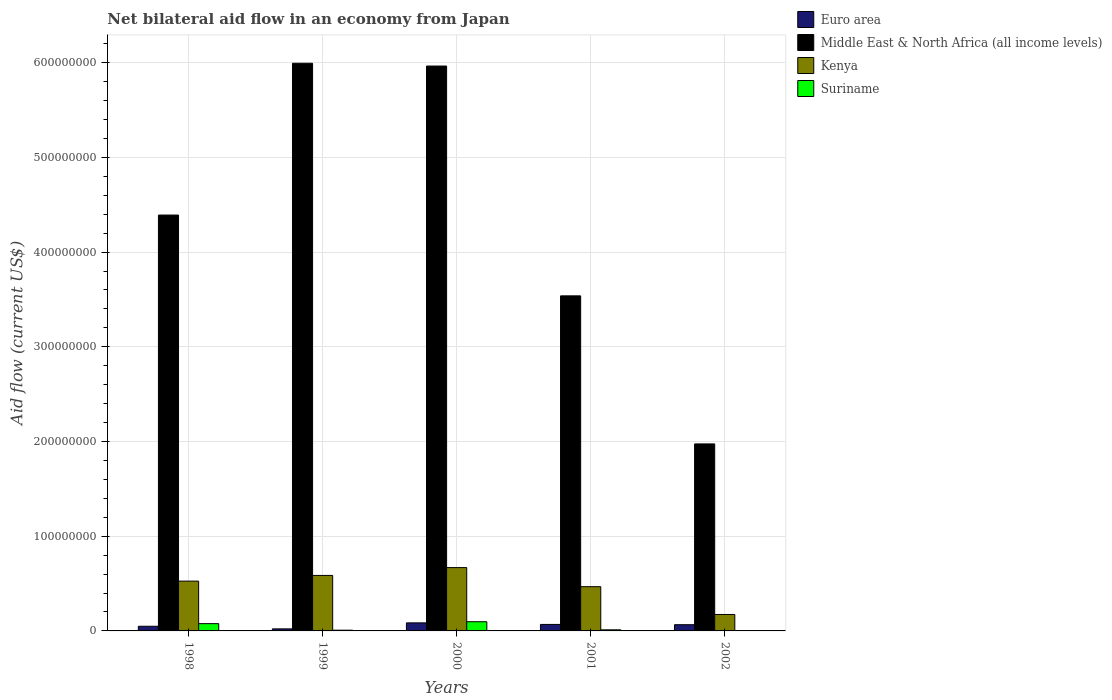How many different coloured bars are there?
Give a very brief answer. 4. How many groups of bars are there?
Your response must be concise. 5. Are the number of bars on each tick of the X-axis equal?
Provide a short and direct response. Yes. How many bars are there on the 5th tick from the left?
Your answer should be very brief. 4. What is the label of the 2nd group of bars from the left?
Your response must be concise. 1999. In how many cases, is the number of bars for a given year not equal to the number of legend labels?
Keep it short and to the point. 0. What is the net bilateral aid flow in Suriname in 2001?
Your answer should be compact. 1.17e+06. Across all years, what is the maximum net bilateral aid flow in Suriname?
Ensure brevity in your answer.  9.70e+06. Across all years, what is the minimum net bilateral aid flow in Euro area?
Offer a terse response. 2.17e+06. In which year was the net bilateral aid flow in Suriname maximum?
Provide a short and direct response. 2000. What is the total net bilateral aid flow in Suriname in the graph?
Your response must be concise. 1.97e+07. What is the difference between the net bilateral aid flow in Middle East & North Africa (all income levels) in 1998 and that in 2000?
Offer a terse response. -1.57e+08. What is the difference between the net bilateral aid flow in Euro area in 2000 and the net bilateral aid flow in Kenya in 2002?
Provide a short and direct response. -8.86e+06. What is the average net bilateral aid flow in Kenya per year?
Make the answer very short. 4.84e+07. In the year 2001, what is the difference between the net bilateral aid flow in Euro area and net bilateral aid flow in Middle East & North Africa (all income levels)?
Keep it short and to the point. -3.47e+08. In how many years, is the net bilateral aid flow in Middle East & North Africa (all income levels) greater than 480000000 US$?
Your response must be concise. 2. What is the ratio of the net bilateral aid flow in Suriname in 1999 to that in 2001?
Provide a succinct answer. 0.65. Is the net bilateral aid flow in Euro area in 1998 less than that in 1999?
Keep it short and to the point. No. Is the difference between the net bilateral aid flow in Euro area in 1998 and 1999 greater than the difference between the net bilateral aid flow in Middle East & North Africa (all income levels) in 1998 and 1999?
Offer a terse response. Yes. What is the difference between the highest and the second highest net bilateral aid flow in Suriname?
Make the answer very short. 2.02e+06. What is the difference between the highest and the lowest net bilateral aid flow in Kenya?
Ensure brevity in your answer.  4.95e+07. What does the 2nd bar from the left in 2001 represents?
Your response must be concise. Middle East & North Africa (all income levels). What does the 3rd bar from the right in 2001 represents?
Offer a very short reply. Middle East & North Africa (all income levels). Is it the case that in every year, the sum of the net bilateral aid flow in Middle East & North Africa (all income levels) and net bilateral aid flow in Euro area is greater than the net bilateral aid flow in Suriname?
Your answer should be very brief. Yes. How many bars are there?
Make the answer very short. 20. Are all the bars in the graph horizontal?
Make the answer very short. No. How many years are there in the graph?
Keep it short and to the point. 5. What is the difference between two consecutive major ticks on the Y-axis?
Offer a terse response. 1.00e+08. Are the values on the major ticks of Y-axis written in scientific E-notation?
Keep it short and to the point. No. Does the graph contain any zero values?
Make the answer very short. No. Does the graph contain grids?
Your answer should be very brief. Yes. Where does the legend appear in the graph?
Provide a succinct answer. Top right. How are the legend labels stacked?
Your answer should be compact. Vertical. What is the title of the graph?
Provide a short and direct response. Net bilateral aid flow in an economy from Japan. Does "Angola" appear as one of the legend labels in the graph?
Make the answer very short. No. What is the Aid flow (current US$) of Euro area in 1998?
Your answer should be very brief. 4.93e+06. What is the Aid flow (current US$) in Middle East & North Africa (all income levels) in 1998?
Offer a very short reply. 4.39e+08. What is the Aid flow (current US$) of Kenya in 1998?
Your response must be concise. 5.26e+07. What is the Aid flow (current US$) in Suriname in 1998?
Offer a terse response. 7.68e+06. What is the Aid flow (current US$) in Euro area in 1999?
Your response must be concise. 2.17e+06. What is the Aid flow (current US$) of Middle East & North Africa (all income levels) in 1999?
Your response must be concise. 5.99e+08. What is the Aid flow (current US$) in Kenya in 1999?
Give a very brief answer. 5.86e+07. What is the Aid flow (current US$) of Suriname in 1999?
Provide a short and direct response. 7.60e+05. What is the Aid flow (current US$) in Euro area in 2000?
Ensure brevity in your answer.  8.50e+06. What is the Aid flow (current US$) of Middle East & North Africa (all income levels) in 2000?
Ensure brevity in your answer.  5.96e+08. What is the Aid flow (current US$) of Kenya in 2000?
Offer a very short reply. 6.69e+07. What is the Aid flow (current US$) in Suriname in 2000?
Provide a succinct answer. 9.70e+06. What is the Aid flow (current US$) in Euro area in 2001?
Your answer should be very brief. 6.85e+06. What is the Aid flow (current US$) of Middle East & North Africa (all income levels) in 2001?
Offer a terse response. 3.54e+08. What is the Aid flow (current US$) of Kenya in 2001?
Keep it short and to the point. 4.67e+07. What is the Aid flow (current US$) in Suriname in 2001?
Offer a terse response. 1.17e+06. What is the Aid flow (current US$) of Euro area in 2002?
Offer a terse response. 6.58e+06. What is the Aid flow (current US$) in Middle East & North Africa (all income levels) in 2002?
Make the answer very short. 1.97e+08. What is the Aid flow (current US$) in Kenya in 2002?
Offer a terse response. 1.74e+07. What is the Aid flow (current US$) of Suriname in 2002?
Offer a terse response. 3.80e+05. Across all years, what is the maximum Aid flow (current US$) of Euro area?
Your answer should be compact. 8.50e+06. Across all years, what is the maximum Aid flow (current US$) in Middle East & North Africa (all income levels)?
Ensure brevity in your answer.  5.99e+08. Across all years, what is the maximum Aid flow (current US$) of Kenya?
Ensure brevity in your answer.  6.69e+07. Across all years, what is the maximum Aid flow (current US$) in Suriname?
Offer a terse response. 9.70e+06. Across all years, what is the minimum Aid flow (current US$) of Euro area?
Offer a very short reply. 2.17e+06. Across all years, what is the minimum Aid flow (current US$) in Middle East & North Africa (all income levels)?
Your answer should be very brief. 1.97e+08. Across all years, what is the minimum Aid flow (current US$) of Kenya?
Make the answer very short. 1.74e+07. What is the total Aid flow (current US$) of Euro area in the graph?
Offer a very short reply. 2.90e+07. What is the total Aid flow (current US$) of Middle East & North Africa (all income levels) in the graph?
Give a very brief answer. 2.19e+09. What is the total Aid flow (current US$) in Kenya in the graph?
Provide a short and direct response. 2.42e+08. What is the total Aid flow (current US$) in Suriname in the graph?
Provide a succinct answer. 1.97e+07. What is the difference between the Aid flow (current US$) of Euro area in 1998 and that in 1999?
Ensure brevity in your answer.  2.76e+06. What is the difference between the Aid flow (current US$) of Middle East & North Africa (all income levels) in 1998 and that in 1999?
Keep it short and to the point. -1.60e+08. What is the difference between the Aid flow (current US$) in Kenya in 1998 and that in 1999?
Keep it short and to the point. -6.00e+06. What is the difference between the Aid flow (current US$) in Suriname in 1998 and that in 1999?
Your response must be concise. 6.92e+06. What is the difference between the Aid flow (current US$) of Euro area in 1998 and that in 2000?
Offer a very short reply. -3.57e+06. What is the difference between the Aid flow (current US$) of Middle East & North Africa (all income levels) in 1998 and that in 2000?
Ensure brevity in your answer.  -1.57e+08. What is the difference between the Aid flow (current US$) of Kenya in 1998 and that in 2000?
Offer a very short reply. -1.43e+07. What is the difference between the Aid flow (current US$) in Suriname in 1998 and that in 2000?
Provide a succinct answer. -2.02e+06. What is the difference between the Aid flow (current US$) of Euro area in 1998 and that in 2001?
Provide a succinct answer. -1.92e+06. What is the difference between the Aid flow (current US$) of Middle East & North Africa (all income levels) in 1998 and that in 2001?
Make the answer very short. 8.53e+07. What is the difference between the Aid flow (current US$) in Kenya in 1998 and that in 2001?
Provide a succinct answer. 5.88e+06. What is the difference between the Aid flow (current US$) in Suriname in 1998 and that in 2001?
Give a very brief answer. 6.51e+06. What is the difference between the Aid flow (current US$) of Euro area in 1998 and that in 2002?
Offer a terse response. -1.65e+06. What is the difference between the Aid flow (current US$) of Middle East & North Africa (all income levels) in 1998 and that in 2002?
Provide a short and direct response. 2.42e+08. What is the difference between the Aid flow (current US$) of Kenya in 1998 and that in 2002?
Offer a very short reply. 3.52e+07. What is the difference between the Aid flow (current US$) in Suriname in 1998 and that in 2002?
Provide a short and direct response. 7.30e+06. What is the difference between the Aid flow (current US$) of Euro area in 1999 and that in 2000?
Ensure brevity in your answer.  -6.33e+06. What is the difference between the Aid flow (current US$) in Middle East & North Africa (all income levels) in 1999 and that in 2000?
Keep it short and to the point. 2.94e+06. What is the difference between the Aid flow (current US$) of Kenya in 1999 and that in 2000?
Provide a succinct answer. -8.27e+06. What is the difference between the Aid flow (current US$) in Suriname in 1999 and that in 2000?
Offer a terse response. -8.94e+06. What is the difference between the Aid flow (current US$) in Euro area in 1999 and that in 2001?
Give a very brief answer. -4.68e+06. What is the difference between the Aid flow (current US$) of Middle East & North Africa (all income levels) in 1999 and that in 2001?
Your answer should be very brief. 2.46e+08. What is the difference between the Aid flow (current US$) of Kenya in 1999 and that in 2001?
Give a very brief answer. 1.19e+07. What is the difference between the Aid flow (current US$) of Suriname in 1999 and that in 2001?
Your answer should be compact. -4.10e+05. What is the difference between the Aid flow (current US$) of Euro area in 1999 and that in 2002?
Provide a short and direct response. -4.41e+06. What is the difference between the Aid flow (current US$) in Middle East & North Africa (all income levels) in 1999 and that in 2002?
Provide a succinct answer. 4.02e+08. What is the difference between the Aid flow (current US$) of Kenya in 1999 and that in 2002?
Provide a short and direct response. 4.12e+07. What is the difference between the Aid flow (current US$) in Euro area in 2000 and that in 2001?
Your response must be concise. 1.65e+06. What is the difference between the Aid flow (current US$) in Middle East & North Africa (all income levels) in 2000 and that in 2001?
Give a very brief answer. 2.43e+08. What is the difference between the Aid flow (current US$) in Kenya in 2000 and that in 2001?
Offer a very short reply. 2.02e+07. What is the difference between the Aid flow (current US$) in Suriname in 2000 and that in 2001?
Make the answer very short. 8.53e+06. What is the difference between the Aid flow (current US$) of Euro area in 2000 and that in 2002?
Keep it short and to the point. 1.92e+06. What is the difference between the Aid flow (current US$) of Middle East & North Africa (all income levels) in 2000 and that in 2002?
Offer a terse response. 3.99e+08. What is the difference between the Aid flow (current US$) of Kenya in 2000 and that in 2002?
Offer a very short reply. 4.95e+07. What is the difference between the Aid flow (current US$) of Suriname in 2000 and that in 2002?
Provide a short and direct response. 9.32e+06. What is the difference between the Aid flow (current US$) of Euro area in 2001 and that in 2002?
Your answer should be compact. 2.70e+05. What is the difference between the Aid flow (current US$) of Middle East & North Africa (all income levels) in 2001 and that in 2002?
Offer a very short reply. 1.56e+08. What is the difference between the Aid flow (current US$) of Kenya in 2001 and that in 2002?
Offer a terse response. 2.94e+07. What is the difference between the Aid flow (current US$) in Suriname in 2001 and that in 2002?
Keep it short and to the point. 7.90e+05. What is the difference between the Aid flow (current US$) in Euro area in 1998 and the Aid flow (current US$) in Middle East & North Africa (all income levels) in 1999?
Keep it short and to the point. -5.94e+08. What is the difference between the Aid flow (current US$) of Euro area in 1998 and the Aid flow (current US$) of Kenya in 1999?
Provide a succinct answer. -5.37e+07. What is the difference between the Aid flow (current US$) in Euro area in 1998 and the Aid flow (current US$) in Suriname in 1999?
Make the answer very short. 4.17e+06. What is the difference between the Aid flow (current US$) of Middle East & North Africa (all income levels) in 1998 and the Aid flow (current US$) of Kenya in 1999?
Offer a terse response. 3.81e+08. What is the difference between the Aid flow (current US$) of Middle East & North Africa (all income levels) in 1998 and the Aid flow (current US$) of Suriname in 1999?
Your response must be concise. 4.38e+08. What is the difference between the Aid flow (current US$) of Kenya in 1998 and the Aid flow (current US$) of Suriname in 1999?
Offer a very short reply. 5.18e+07. What is the difference between the Aid flow (current US$) in Euro area in 1998 and the Aid flow (current US$) in Middle East & North Africa (all income levels) in 2000?
Your response must be concise. -5.92e+08. What is the difference between the Aid flow (current US$) in Euro area in 1998 and the Aid flow (current US$) in Kenya in 2000?
Keep it short and to the point. -6.19e+07. What is the difference between the Aid flow (current US$) of Euro area in 1998 and the Aid flow (current US$) of Suriname in 2000?
Your response must be concise. -4.77e+06. What is the difference between the Aid flow (current US$) of Middle East & North Africa (all income levels) in 1998 and the Aid flow (current US$) of Kenya in 2000?
Keep it short and to the point. 3.72e+08. What is the difference between the Aid flow (current US$) in Middle East & North Africa (all income levels) in 1998 and the Aid flow (current US$) in Suriname in 2000?
Offer a very short reply. 4.29e+08. What is the difference between the Aid flow (current US$) of Kenya in 1998 and the Aid flow (current US$) of Suriname in 2000?
Give a very brief answer. 4.29e+07. What is the difference between the Aid flow (current US$) of Euro area in 1998 and the Aid flow (current US$) of Middle East & North Africa (all income levels) in 2001?
Make the answer very short. -3.49e+08. What is the difference between the Aid flow (current US$) in Euro area in 1998 and the Aid flow (current US$) in Kenya in 2001?
Provide a short and direct response. -4.18e+07. What is the difference between the Aid flow (current US$) of Euro area in 1998 and the Aid flow (current US$) of Suriname in 2001?
Offer a very short reply. 3.76e+06. What is the difference between the Aid flow (current US$) in Middle East & North Africa (all income levels) in 1998 and the Aid flow (current US$) in Kenya in 2001?
Give a very brief answer. 3.92e+08. What is the difference between the Aid flow (current US$) in Middle East & North Africa (all income levels) in 1998 and the Aid flow (current US$) in Suriname in 2001?
Offer a very short reply. 4.38e+08. What is the difference between the Aid flow (current US$) of Kenya in 1998 and the Aid flow (current US$) of Suriname in 2001?
Provide a succinct answer. 5.14e+07. What is the difference between the Aid flow (current US$) of Euro area in 1998 and the Aid flow (current US$) of Middle East & North Africa (all income levels) in 2002?
Offer a very short reply. -1.93e+08. What is the difference between the Aid flow (current US$) in Euro area in 1998 and the Aid flow (current US$) in Kenya in 2002?
Your response must be concise. -1.24e+07. What is the difference between the Aid flow (current US$) in Euro area in 1998 and the Aid flow (current US$) in Suriname in 2002?
Your response must be concise. 4.55e+06. What is the difference between the Aid flow (current US$) of Middle East & North Africa (all income levels) in 1998 and the Aid flow (current US$) of Kenya in 2002?
Your response must be concise. 4.22e+08. What is the difference between the Aid flow (current US$) of Middle East & North Africa (all income levels) in 1998 and the Aid flow (current US$) of Suriname in 2002?
Your answer should be very brief. 4.39e+08. What is the difference between the Aid flow (current US$) in Kenya in 1998 and the Aid flow (current US$) in Suriname in 2002?
Your answer should be compact. 5.22e+07. What is the difference between the Aid flow (current US$) of Euro area in 1999 and the Aid flow (current US$) of Middle East & North Africa (all income levels) in 2000?
Keep it short and to the point. -5.94e+08. What is the difference between the Aid flow (current US$) in Euro area in 1999 and the Aid flow (current US$) in Kenya in 2000?
Offer a very short reply. -6.47e+07. What is the difference between the Aid flow (current US$) of Euro area in 1999 and the Aid flow (current US$) of Suriname in 2000?
Keep it short and to the point. -7.53e+06. What is the difference between the Aid flow (current US$) of Middle East & North Africa (all income levels) in 1999 and the Aid flow (current US$) of Kenya in 2000?
Your answer should be compact. 5.33e+08. What is the difference between the Aid flow (current US$) of Middle East & North Africa (all income levels) in 1999 and the Aid flow (current US$) of Suriname in 2000?
Provide a short and direct response. 5.90e+08. What is the difference between the Aid flow (current US$) in Kenya in 1999 and the Aid flow (current US$) in Suriname in 2000?
Offer a very short reply. 4.89e+07. What is the difference between the Aid flow (current US$) in Euro area in 1999 and the Aid flow (current US$) in Middle East & North Africa (all income levels) in 2001?
Ensure brevity in your answer.  -3.52e+08. What is the difference between the Aid flow (current US$) in Euro area in 1999 and the Aid flow (current US$) in Kenya in 2001?
Offer a very short reply. -4.45e+07. What is the difference between the Aid flow (current US$) in Euro area in 1999 and the Aid flow (current US$) in Suriname in 2001?
Offer a terse response. 1.00e+06. What is the difference between the Aid flow (current US$) of Middle East & North Africa (all income levels) in 1999 and the Aid flow (current US$) of Kenya in 2001?
Offer a very short reply. 5.53e+08. What is the difference between the Aid flow (current US$) in Middle East & North Africa (all income levels) in 1999 and the Aid flow (current US$) in Suriname in 2001?
Give a very brief answer. 5.98e+08. What is the difference between the Aid flow (current US$) of Kenya in 1999 and the Aid flow (current US$) of Suriname in 2001?
Provide a succinct answer. 5.74e+07. What is the difference between the Aid flow (current US$) of Euro area in 1999 and the Aid flow (current US$) of Middle East & North Africa (all income levels) in 2002?
Your response must be concise. -1.95e+08. What is the difference between the Aid flow (current US$) of Euro area in 1999 and the Aid flow (current US$) of Kenya in 2002?
Offer a terse response. -1.52e+07. What is the difference between the Aid flow (current US$) of Euro area in 1999 and the Aid flow (current US$) of Suriname in 2002?
Make the answer very short. 1.79e+06. What is the difference between the Aid flow (current US$) in Middle East & North Africa (all income levels) in 1999 and the Aid flow (current US$) in Kenya in 2002?
Give a very brief answer. 5.82e+08. What is the difference between the Aid flow (current US$) of Middle East & North Africa (all income levels) in 1999 and the Aid flow (current US$) of Suriname in 2002?
Keep it short and to the point. 5.99e+08. What is the difference between the Aid flow (current US$) in Kenya in 1999 and the Aid flow (current US$) in Suriname in 2002?
Provide a succinct answer. 5.82e+07. What is the difference between the Aid flow (current US$) in Euro area in 2000 and the Aid flow (current US$) in Middle East & North Africa (all income levels) in 2001?
Your answer should be very brief. -3.45e+08. What is the difference between the Aid flow (current US$) of Euro area in 2000 and the Aid flow (current US$) of Kenya in 2001?
Give a very brief answer. -3.82e+07. What is the difference between the Aid flow (current US$) of Euro area in 2000 and the Aid flow (current US$) of Suriname in 2001?
Keep it short and to the point. 7.33e+06. What is the difference between the Aid flow (current US$) of Middle East & North Africa (all income levels) in 2000 and the Aid flow (current US$) of Kenya in 2001?
Provide a short and direct response. 5.50e+08. What is the difference between the Aid flow (current US$) of Middle East & North Africa (all income levels) in 2000 and the Aid flow (current US$) of Suriname in 2001?
Provide a succinct answer. 5.95e+08. What is the difference between the Aid flow (current US$) in Kenya in 2000 and the Aid flow (current US$) in Suriname in 2001?
Your answer should be very brief. 6.57e+07. What is the difference between the Aid flow (current US$) of Euro area in 2000 and the Aid flow (current US$) of Middle East & North Africa (all income levels) in 2002?
Ensure brevity in your answer.  -1.89e+08. What is the difference between the Aid flow (current US$) in Euro area in 2000 and the Aid flow (current US$) in Kenya in 2002?
Make the answer very short. -8.86e+06. What is the difference between the Aid flow (current US$) of Euro area in 2000 and the Aid flow (current US$) of Suriname in 2002?
Provide a short and direct response. 8.12e+06. What is the difference between the Aid flow (current US$) in Middle East & North Africa (all income levels) in 2000 and the Aid flow (current US$) in Kenya in 2002?
Your answer should be very brief. 5.79e+08. What is the difference between the Aid flow (current US$) in Middle East & North Africa (all income levels) in 2000 and the Aid flow (current US$) in Suriname in 2002?
Make the answer very short. 5.96e+08. What is the difference between the Aid flow (current US$) in Kenya in 2000 and the Aid flow (current US$) in Suriname in 2002?
Give a very brief answer. 6.65e+07. What is the difference between the Aid flow (current US$) in Euro area in 2001 and the Aid flow (current US$) in Middle East & North Africa (all income levels) in 2002?
Provide a short and direct response. -1.91e+08. What is the difference between the Aid flow (current US$) in Euro area in 2001 and the Aid flow (current US$) in Kenya in 2002?
Keep it short and to the point. -1.05e+07. What is the difference between the Aid flow (current US$) of Euro area in 2001 and the Aid flow (current US$) of Suriname in 2002?
Offer a very short reply. 6.47e+06. What is the difference between the Aid flow (current US$) in Middle East & North Africa (all income levels) in 2001 and the Aid flow (current US$) in Kenya in 2002?
Your response must be concise. 3.36e+08. What is the difference between the Aid flow (current US$) in Middle East & North Africa (all income levels) in 2001 and the Aid flow (current US$) in Suriname in 2002?
Give a very brief answer. 3.53e+08. What is the difference between the Aid flow (current US$) in Kenya in 2001 and the Aid flow (current US$) in Suriname in 2002?
Make the answer very short. 4.63e+07. What is the average Aid flow (current US$) of Euro area per year?
Offer a very short reply. 5.81e+06. What is the average Aid flow (current US$) in Middle East & North Africa (all income levels) per year?
Keep it short and to the point. 4.37e+08. What is the average Aid flow (current US$) of Kenya per year?
Your response must be concise. 4.84e+07. What is the average Aid flow (current US$) of Suriname per year?
Offer a very short reply. 3.94e+06. In the year 1998, what is the difference between the Aid flow (current US$) in Euro area and Aid flow (current US$) in Middle East & North Africa (all income levels)?
Your answer should be very brief. -4.34e+08. In the year 1998, what is the difference between the Aid flow (current US$) in Euro area and Aid flow (current US$) in Kenya?
Your response must be concise. -4.77e+07. In the year 1998, what is the difference between the Aid flow (current US$) of Euro area and Aid flow (current US$) of Suriname?
Your response must be concise. -2.75e+06. In the year 1998, what is the difference between the Aid flow (current US$) in Middle East & North Africa (all income levels) and Aid flow (current US$) in Kenya?
Keep it short and to the point. 3.87e+08. In the year 1998, what is the difference between the Aid flow (current US$) of Middle East & North Africa (all income levels) and Aid flow (current US$) of Suriname?
Your answer should be very brief. 4.31e+08. In the year 1998, what is the difference between the Aid flow (current US$) in Kenya and Aid flow (current US$) in Suriname?
Ensure brevity in your answer.  4.49e+07. In the year 1999, what is the difference between the Aid flow (current US$) in Euro area and Aid flow (current US$) in Middle East & North Africa (all income levels)?
Give a very brief answer. -5.97e+08. In the year 1999, what is the difference between the Aid flow (current US$) in Euro area and Aid flow (current US$) in Kenya?
Your answer should be compact. -5.64e+07. In the year 1999, what is the difference between the Aid flow (current US$) in Euro area and Aid flow (current US$) in Suriname?
Your response must be concise. 1.41e+06. In the year 1999, what is the difference between the Aid flow (current US$) in Middle East & North Africa (all income levels) and Aid flow (current US$) in Kenya?
Keep it short and to the point. 5.41e+08. In the year 1999, what is the difference between the Aid flow (current US$) in Middle East & North Africa (all income levels) and Aid flow (current US$) in Suriname?
Offer a very short reply. 5.99e+08. In the year 1999, what is the difference between the Aid flow (current US$) in Kenya and Aid flow (current US$) in Suriname?
Offer a terse response. 5.78e+07. In the year 2000, what is the difference between the Aid flow (current US$) of Euro area and Aid flow (current US$) of Middle East & North Africa (all income levels)?
Make the answer very short. -5.88e+08. In the year 2000, what is the difference between the Aid flow (current US$) in Euro area and Aid flow (current US$) in Kenya?
Your answer should be very brief. -5.84e+07. In the year 2000, what is the difference between the Aid flow (current US$) of Euro area and Aid flow (current US$) of Suriname?
Offer a terse response. -1.20e+06. In the year 2000, what is the difference between the Aid flow (current US$) in Middle East & North Africa (all income levels) and Aid flow (current US$) in Kenya?
Your answer should be compact. 5.30e+08. In the year 2000, what is the difference between the Aid flow (current US$) in Middle East & North Africa (all income levels) and Aid flow (current US$) in Suriname?
Provide a short and direct response. 5.87e+08. In the year 2000, what is the difference between the Aid flow (current US$) of Kenya and Aid flow (current US$) of Suriname?
Offer a very short reply. 5.72e+07. In the year 2001, what is the difference between the Aid flow (current US$) in Euro area and Aid flow (current US$) in Middle East & North Africa (all income levels)?
Ensure brevity in your answer.  -3.47e+08. In the year 2001, what is the difference between the Aid flow (current US$) in Euro area and Aid flow (current US$) in Kenya?
Ensure brevity in your answer.  -3.99e+07. In the year 2001, what is the difference between the Aid flow (current US$) of Euro area and Aid flow (current US$) of Suriname?
Provide a short and direct response. 5.68e+06. In the year 2001, what is the difference between the Aid flow (current US$) of Middle East & North Africa (all income levels) and Aid flow (current US$) of Kenya?
Offer a terse response. 3.07e+08. In the year 2001, what is the difference between the Aid flow (current US$) of Middle East & North Africa (all income levels) and Aid flow (current US$) of Suriname?
Offer a very short reply. 3.53e+08. In the year 2001, what is the difference between the Aid flow (current US$) in Kenya and Aid flow (current US$) in Suriname?
Give a very brief answer. 4.55e+07. In the year 2002, what is the difference between the Aid flow (current US$) in Euro area and Aid flow (current US$) in Middle East & North Africa (all income levels)?
Ensure brevity in your answer.  -1.91e+08. In the year 2002, what is the difference between the Aid flow (current US$) of Euro area and Aid flow (current US$) of Kenya?
Offer a very short reply. -1.08e+07. In the year 2002, what is the difference between the Aid flow (current US$) in Euro area and Aid flow (current US$) in Suriname?
Give a very brief answer. 6.20e+06. In the year 2002, what is the difference between the Aid flow (current US$) in Middle East & North Africa (all income levels) and Aid flow (current US$) in Kenya?
Offer a terse response. 1.80e+08. In the year 2002, what is the difference between the Aid flow (current US$) of Middle East & North Africa (all income levels) and Aid flow (current US$) of Suriname?
Offer a very short reply. 1.97e+08. In the year 2002, what is the difference between the Aid flow (current US$) of Kenya and Aid flow (current US$) of Suriname?
Offer a very short reply. 1.70e+07. What is the ratio of the Aid flow (current US$) in Euro area in 1998 to that in 1999?
Make the answer very short. 2.27. What is the ratio of the Aid flow (current US$) in Middle East & North Africa (all income levels) in 1998 to that in 1999?
Provide a succinct answer. 0.73. What is the ratio of the Aid flow (current US$) in Kenya in 1998 to that in 1999?
Your answer should be very brief. 0.9. What is the ratio of the Aid flow (current US$) in Suriname in 1998 to that in 1999?
Offer a terse response. 10.11. What is the ratio of the Aid flow (current US$) in Euro area in 1998 to that in 2000?
Make the answer very short. 0.58. What is the ratio of the Aid flow (current US$) in Middle East & North Africa (all income levels) in 1998 to that in 2000?
Make the answer very short. 0.74. What is the ratio of the Aid flow (current US$) of Kenya in 1998 to that in 2000?
Your answer should be very brief. 0.79. What is the ratio of the Aid flow (current US$) in Suriname in 1998 to that in 2000?
Your answer should be very brief. 0.79. What is the ratio of the Aid flow (current US$) of Euro area in 1998 to that in 2001?
Your response must be concise. 0.72. What is the ratio of the Aid flow (current US$) in Middle East & North Africa (all income levels) in 1998 to that in 2001?
Provide a short and direct response. 1.24. What is the ratio of the Aid flow (current US$) of Kenya in 1998 to that in 2001?
Keep it short and to the point. 1.13. What is the ratio of the Aid flow (current US$) in Suriname in 1998 to that in 2001?
Ensure brevity in your answer.  6.56. What is the ratio of the Aid flow (current US$) in Euro area in 1998 to that in 2002?
Give a very brief answer. 0.75. What is the ratio of the Aid flow (current US$) of Middle East & North Africa (all income levels) in 1998 to that in 2002?
Your response must be concise. 2.22. What is the ratio of the Aid flow (current US$) in Kenya in 1998 to that in 2002?
Your response must be concise. 3.03. What is the ratio of the Aid flow (current US$) in Suriname in 1998 to that in 2002?
Provide a succinct answer. 20.21. What is the ratio of the Aid flow (current US$) of Euro area in 1999 to that in 2000?
Offer a terse response. 0.26. What is the ratio of the Aid flow (current US$) in Kenya in 1999 to that in 2000?
Provide a short and direct response. 0.88. What is the ratio of the Aid flow (current US$) of Suriname in 1999 to that in 2000?
Offer a very short reply. 0.08. What is the ratio of the Aid flow (current US$) in Euro area in 1999 to that in 2001?
Give a very brief answer. 0.32. What is the ratio of the Aid flow (current US$) in Middle East & North Africa (all income levels) in 1999 to that in 2001?
Your response must be concise. 1.69. What is the ratio of the Aid flow (current US$) in Kenya in 1999 to that in 2001?
Your answer should be compact. 1.25. What is the ratio of the Aid flow (current US$) of Suriname in 1999 to that in 2001?
Give a very brief answer. 0.65. What is the ratio of the Aid flow (current US$) in Euro area in 1999 to that in 2002?
Provide a succinct answer. 0.33. What is the ratio of the Aid flow (current US$) in Middle East & North Africa (all income levels) in 1999 to that in 2002?
Provide a short and direct response. 3.04. What is the ratio of the Aid flow (current US$) of Kenya in 1999 to that in 2002?
Give a very brief answer. 3.38. What is the ratio of the Aid flow (current US$) in Suriname in 1999 to that in 2002?
Ensure brevity in your answer.  2. What is the ratio of the Aid flow (current US$) of Euro area in 2000 to that in 2001?
Your response must be concise. 1.24. What is the ratio of the Aid flow (current US$) of Middle East & North Africa (all income levels) in 2000 to that in 2001?
Give a very brief answer. 1.69. What is the ratio of the Aid flow (current US$) in Kenya in 2000 to that in 2001?
Give a very brief answer. 1.43. What is the ratio of the Aid flow (current US$) of Suriname in 2000 to that in 2001?
Your response must be concise. 8.29. What is the ratio of the Aid flow (current US$) in Euro area in 2000 to that in 2002?
Provide a short and direct response. 1.29. What is the ratio of the Aid flow (current US$) in Middle East & North Africa (all income levels) in 2000 to that in 2002?
Your answer should be compact. 3.02. What is the ratio of the Aid flow (current US$) in Kenya in 2000 to that in 2002?
Offer a terse response. 3.85. What is the ratio of the Aid flow (current US$) in Suriname in 2000 to that in 2002?
Your answer should be compact. 25.53. What is the ratio of the Aid flow (current US$) in Euro area in 2001 to that in 2002?
Make the answer very short. 1.04. What is the ratio of the Aid flow (current US$) of Middle East & North Africa (all income levels) in 2001 to that in 2002?
Ensure brevity in your answer.  1.79. What is the ratio of the Aid flow (current US$) of Kenya in 2001 to that in 2002?
Your answer should be compact. 2.69. What is the ratio of the Aid flow (current US$) in Suriname in 2001 to that in 2002?
Make the answer very short. 3.08. What is the difference between the highest and the second highest Aid flow (current US$) of Euro area?
Keep it short and to the point. 1.65e+06. What is the difference between the highest and the second highest Aid flow (current US$) in Middle East & North Africa (all income levels)?
Your response must be concise. 2.94e+06. What is the difference between the highest and the second highest Aid flow (current US$) in Kenya?
Make the answer very short. 8.27e+06. What is the difference between the highest and the second highest Aid flow (current US$) in Suriname?
Your answer should be very brief. 2.02e+06. What is the difference between the highest and the lowest Aid flow (current US$) of Euro area?
Your answer should be compact. 6.33e+06. What is the difference between the highest and the lowest Aid flow (current US$) of Middle East & North Africa (all income levels)?
Ensure brevity in your answer.  4.02e+08. What is the difference between the highest and the lowest Aid flow (current US$) in Kenya?
Provide a succinct answer. 4.95e+07. What is the difference between the highest and the lowest Aid flow (current US$) in Suriname?
Your response must be concise. 9.32e+06. 